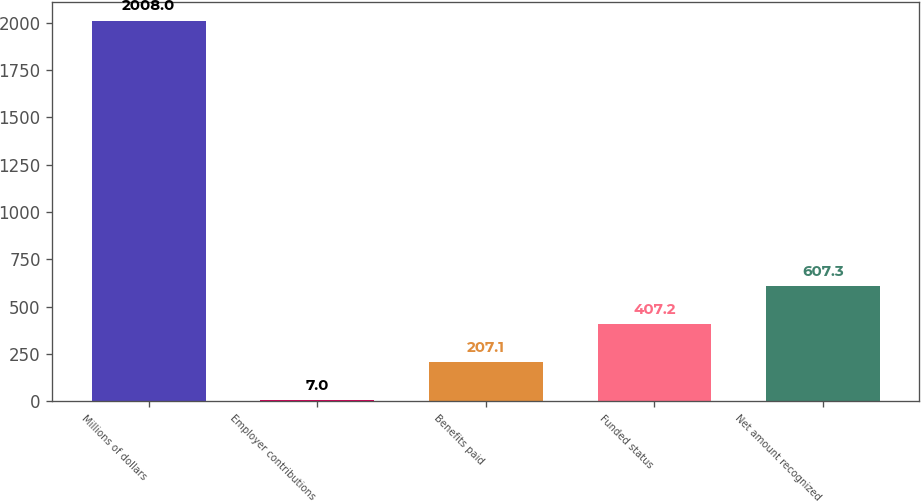<chart> <loc_0><loc_0><loc_500><loc_500><bar_chart><fcel>Millions of dollars<fcel>Employer contributions<fcel>Benefits paid<fcel>Funded status<fcel>Net amount recognized<nl><fcel>2008<fcel>7<fcel>207.1<fcel>407.2<fcel>607.3<nl></chart> 